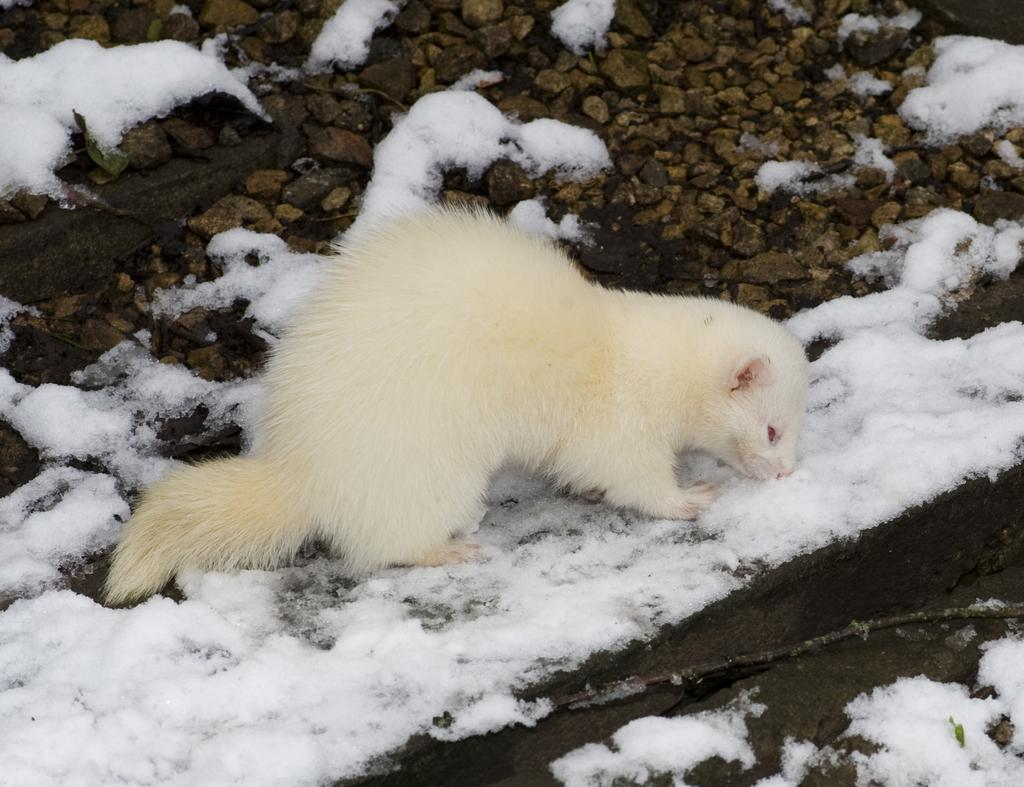What type of animal can be seen in the image? There is an animal in the image, but its specific type cannot be determined from the provided facts. What is the color of the animal in the image? The animal is white in color. What type of terrain is visible in the image? There are stones and white snow visible in the image. What type of liquid is being used to clean the animal's eye in the image? There is no liquid or eye visible in the image, so it is not possible to answer that question. 